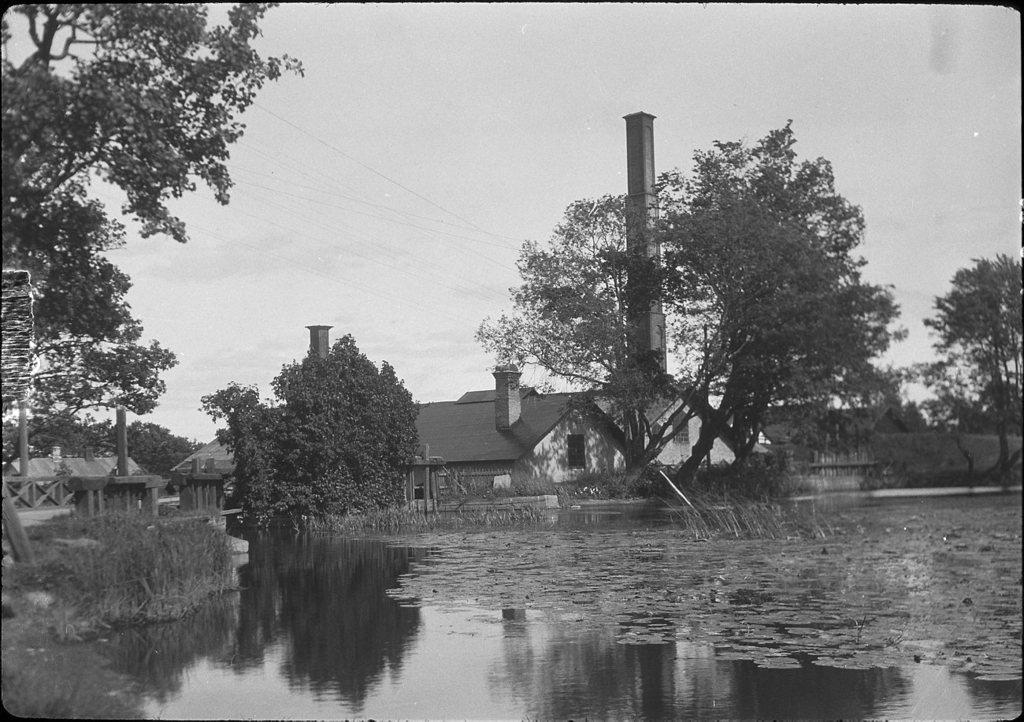What is the color scheme of the image? The image is black and white. What type of natural elements can be seen in the image? There are plants, water, and trees visible in the image. What man-made structures are present in the image? There is a fence, houses, and electric wires visible in the image. What part of the natural environment is visible in the image? The sky is visible in the image. What is the position of the argument in the image? There is no argument present in the image; it is a black and white image featuring plants, water, a fence, houses, electric wires, and the sky. How many people are resting in the image? There are no people visible in the image, so it is not possible to determine how many might be resting. 